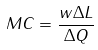Convert formula to latex. <formula><loc_0><loc_0><loc_500><loc_500>M C = \frac { w \Delta L } { \Delta Q }</formula> 